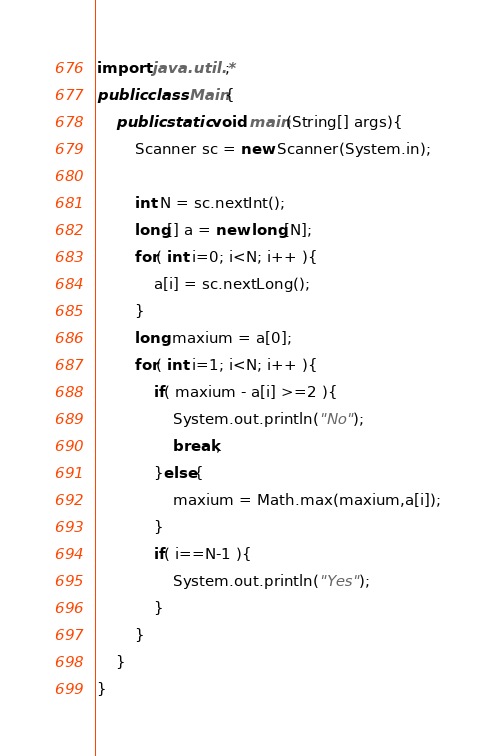Convert code to text. <code><loc_0><loc_0><loc_500><loc_500><_Java_>import java.util.*;
public class Main{
	public static void main(String[] args){
		Scanner sc = new Scanner(System.in);

		int N = sc.nextInt();
		long[] a = new long[N];
		for( int i=0; i<N; i++ ){
			a[i] = sc.nextLong();
		}
		long maxium = a[0];
		for( int i=1; i<N; i++ ){
			if( maxium - a[i] >=2 ){
				System.out.println("No");
				break;
			}else{
				maxium = Math.max(maxium,a[i]);
			}
			if( i==N-1 ){
				System.out.println("Yes");
			}
		}
	}
}
</code> 